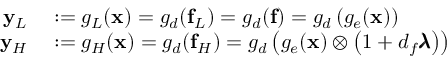<formula> <loc_0><loc_0><loc_500><loc_500>\begin{array} { r l } { y _ { L } } & \colon = g _ { L } ( x ) = g _ { d } ( f _ { L } ) = g _ { d } ( f ) = g _ { d } \left ( g _ { e } ( x ) \right ) } \\ { y _ { H } } & \colon = g _ { H } ( x ) = g _ { d } ( f _ { H } ) = g _ { d } \left ( g _ { e } ( x ) \otimes \left ( 1 + d _ { f } \pm b { \lambda } \right ) \right ) } \end{array}</formula> 